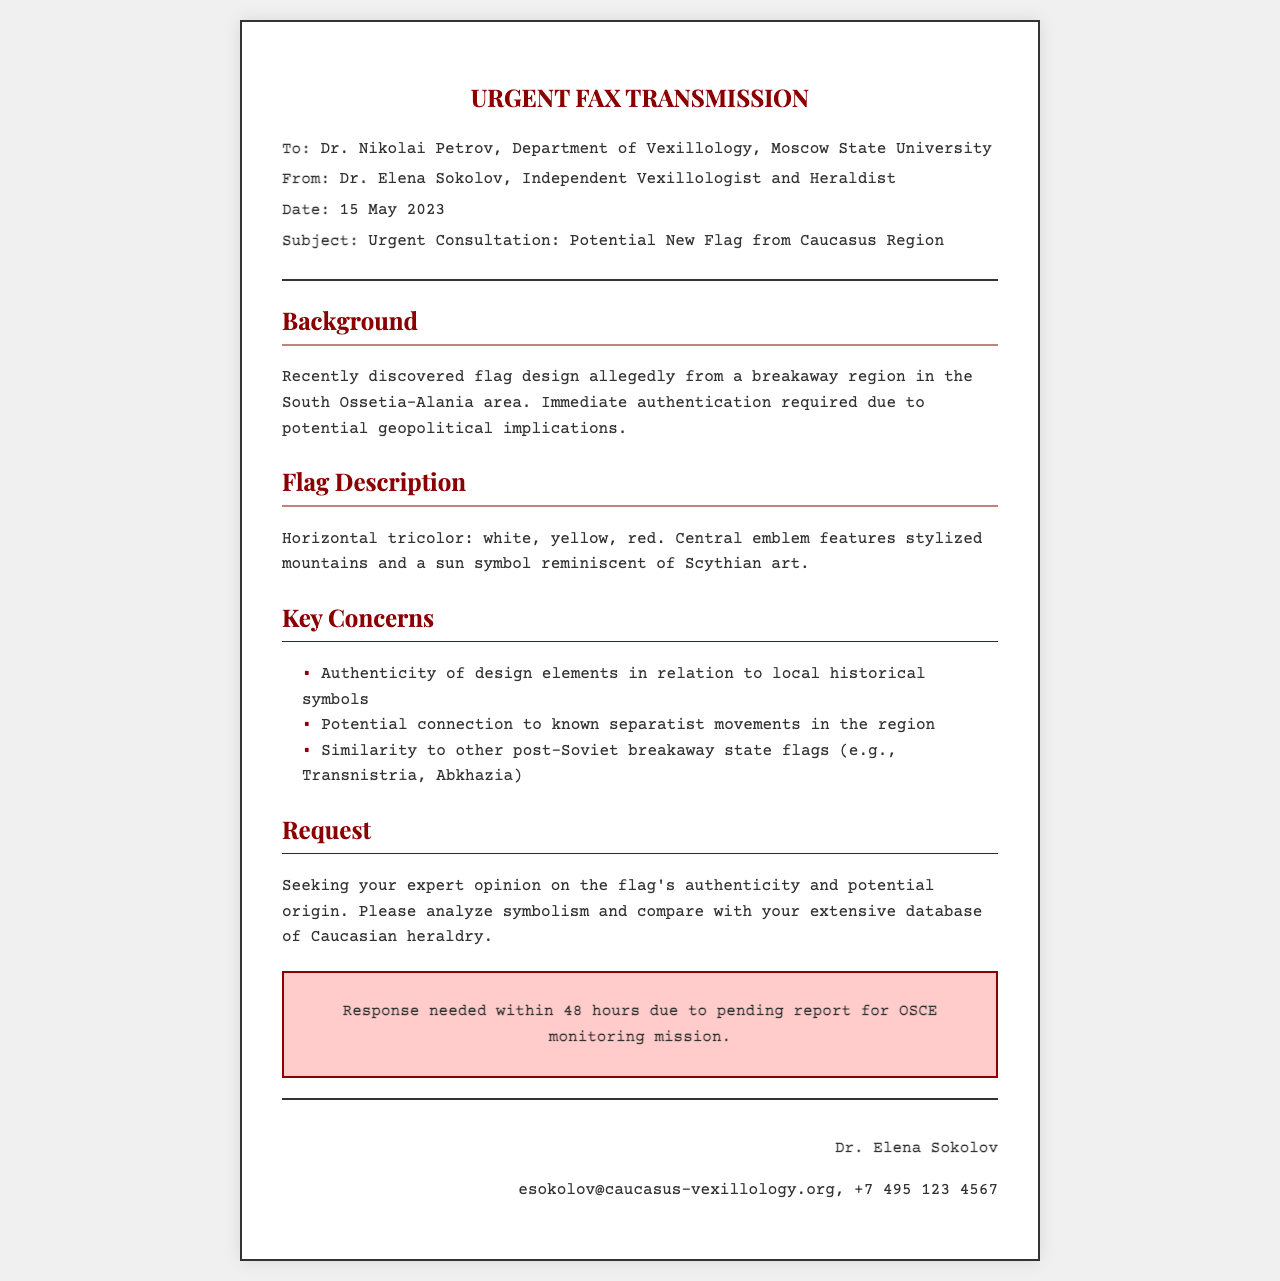What is the date of the fax? The date of the fax is indicated in the document as 15 May 2023.
Answer: 15 May 2023 Who is the sender of the fax? The sender is identified in the document as Dr. Elena Sokolov.
Answer: Dr. Elena Sokolov What are the colors of the flag described? The document lists the flag's colors as white, yellow, and red.
Answer: white, yellow, red What is the central emblem of the flag? The central emblem is described as stylized mountains and a sun symbol.
Answer: stylized mountains and a sun symbol What is the urgency level indicated in the fax? The fax specifies the urgency with a note for a response needed within 48 hours.
Answer: 48 hours What is the main concern about the flag's authenticity? A primary concern is its relation to local historical symbols.
Answer: local historical symbols Who is the recipient of the fax? The recipient of the fax is Dr. Nikolai Petrov.
Answer: Dr. Nikolai Petrov What potential geopolitical implication is mentioned? The document indicates that immediate authentication is required due to potential geopolitical implications.
Answer: geopolitical implications 